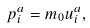Convert formula to latex. <formula><loc_0><loc_0><loc_500><loc_500>p _ { i } ^ { a } = m _ { 0 } u ^ { a } _ { i } ,</formula> 